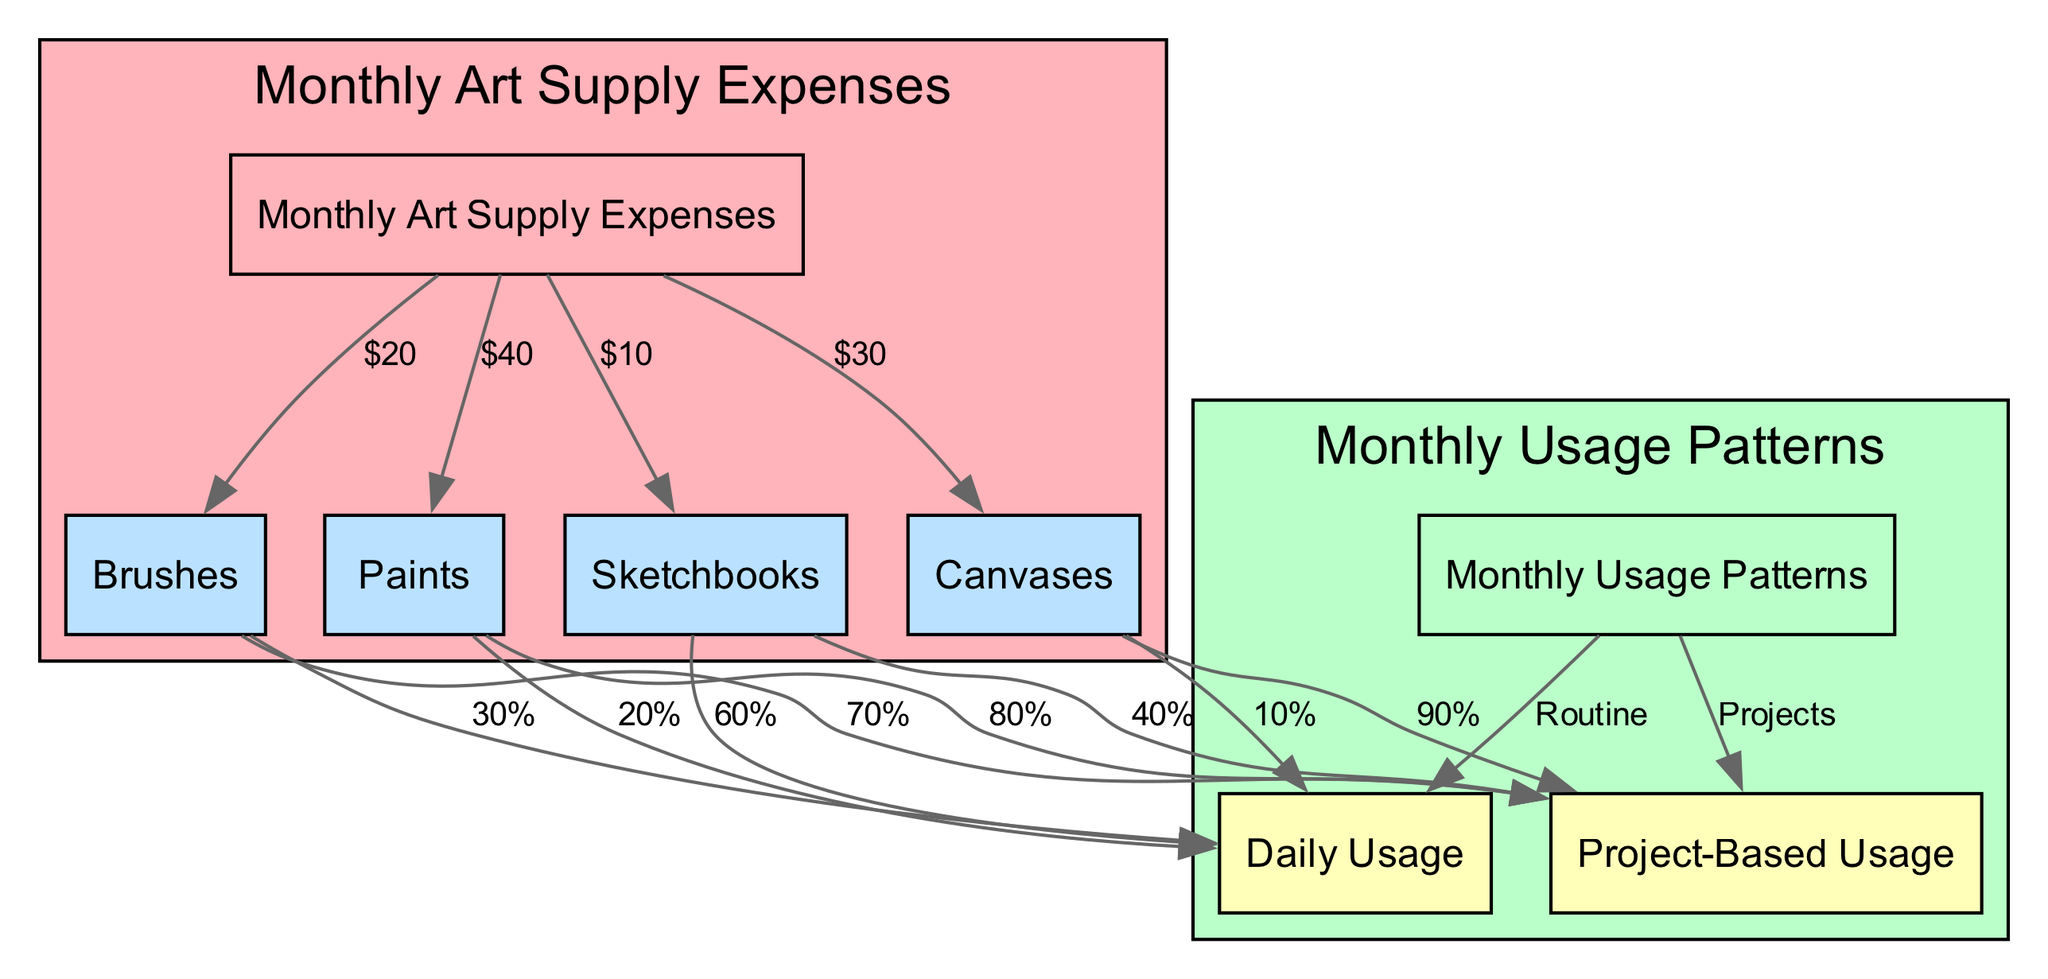What is the total expense for paints? The diagram shows that the edge connecting "Monthly Art Supply Expenses" to "Paints" is labeled with "$40." This indicates that the total expense for paints is 40.
Answer: $40 What percentage of brushes is used for project-based usage? According to the diagram, the edge from "Brushes" to "Project-Based Usage" has a label of "70%." Thus, 70% of brushes are used for project-based usage.
Answer: 70% How many nodes are there in the diagram? The diagram lists a total of 7 distinct nodes: "Monthly Art Supply Expenses," "Paints," "Brushes," "Canvases," "Sketchbooks," "Monthly Usage Patterns," "Daily Usage," and "Project-Based Usage." Thus, the total number of nodes is 7.
Answer: 7 What is the total expense for sketchbooks? The diagram indicates that the edge from "Monthly Art Supply Expenses" to "Sketchbooks" has a label of "$10." Therefore, the total expense for sketchbooks is 10.
Answer: $10 What percentage of canvases is used daily? The edge from "Canvases" to "Daily Usage" in the diagram shows "10%." Therefore, 10% of canvases are used daily.
Answer: 10% How much less is spent on brushes compared to canvases? The diagram indicates that $20 is spent on brushes and $30 is spent on canvases. To find out how much less is spent on brushes than canvases, we subtract $20 from $30, resulting in $10.
Answer: $10 Which material has the highest project-based usage? By analyzing the percentages for project-based usage, "Paints" has 80%, "Brushes" has 70%, "Canvases" has 90%, and "Sketchbooks" has 40%. The material with the highest project-based usage is "Canvases," with 90%.
Answer: Canvases What is the relationship between daily usage and sketchbooks? The edge from "Sketchbooks" to "Daily Usage" is labeled "60%." This indicates that there is a direct relationship where 60% of sketchbooks are used for daily activities.
Answer: 60% What is the total percentage of paints used daily? The diagram indicates that "Paints" has a daily usage percentage of 20%. Therefore, the total percentage of paints used daily is 20%.
Answer: 20% 